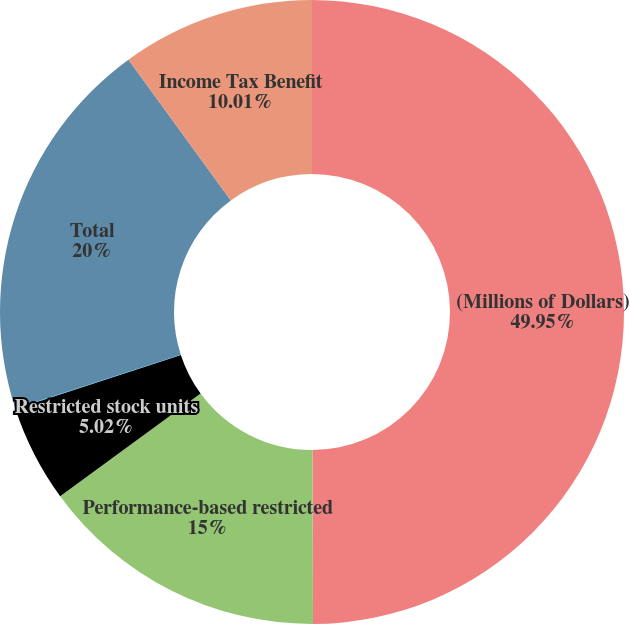Convert chart. <chart><loc_0><loc_0><loc_500><loc_500><pie_chart><fcel>(Millions of Dollars)<fcel>Performance-based restricted<fcel>Restricted stock units<fcel>Non-officer director deferred<fcel>Total<fcel>Income Tax Benefit<nl><fcel>49.95%<fcel>15.0%<fcel>5.02%<fcel>0.02%<fcel>20.0%<fcel>10.01%<nl></chart> 